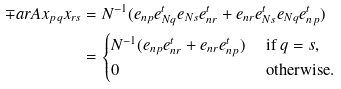<formula> <loc_0><loc_0><loc_500><loc_500>\mp a r { A } { x _ { p q } } { x _ { r s } } & = N ^ { - 1 } ( e _ { n p } e _ { N q } ^ { t } e _ { N s } e _ { n r } ^ { t } + e _ { n r } e _ { N s } ^ { t } e _ { N q } e _ { n p } ^ { t } ) \\ & = \begin{cases} N ^ { - 1 } ( e _ { n p } e _ { n r } ^ { t } + e _ { n r } e _ { n p } ^ { t } ) & \text { if } q = s , \\ 0 & \text { otherwise.} \end{cases}</formula> 